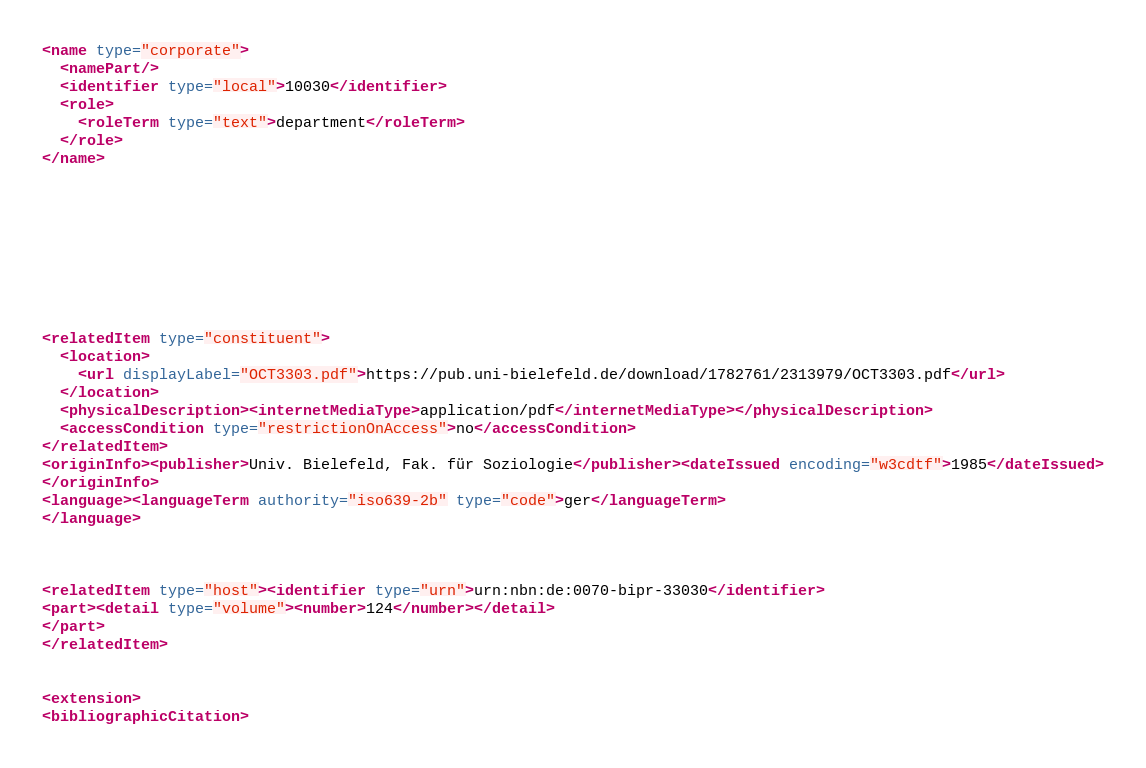<code> <loc_0><loc_0><loc_500><loc_500><_XML_>





<name type="corporate">
  <namePart/>
  <identifier type="local">10030</identifier>
  <role>
    <roleTerm type="text">department</roleTerm>
  </role>
</name>









<relatedItem type="constituent">
  <location>
    <url displayLabel="OCT3303.pdf">https://pub.uni-bielefeld.de/download/1782761/2313979/OCT3303.pdf</url>
  </location>
  <physicalDescription><internetMediaType>application/pdf</internetMediaType></physicalDescription>
  <accessCondition type="restrictionOnAccess">no</accessCondition>
</relatedItem>
<originInfo><publisher>Univ. Bielefeld, Fak. für Soziologie</publisher><dateIssued encoding="w3cdtf">1985</dateIssued>
</originInfo>
<language><languageTerm authority="iso639-2b" type="code">ger</languageTerm>
</language>



<relatedItem type="host"><identifier type="urn">urn:nbn:de:0070-bipr-33030</identifier>
<part><detail type="volume"><number>124</number></detail>
</part>
</relatedItem>


<extension>
<bibliographicCitation></code> 